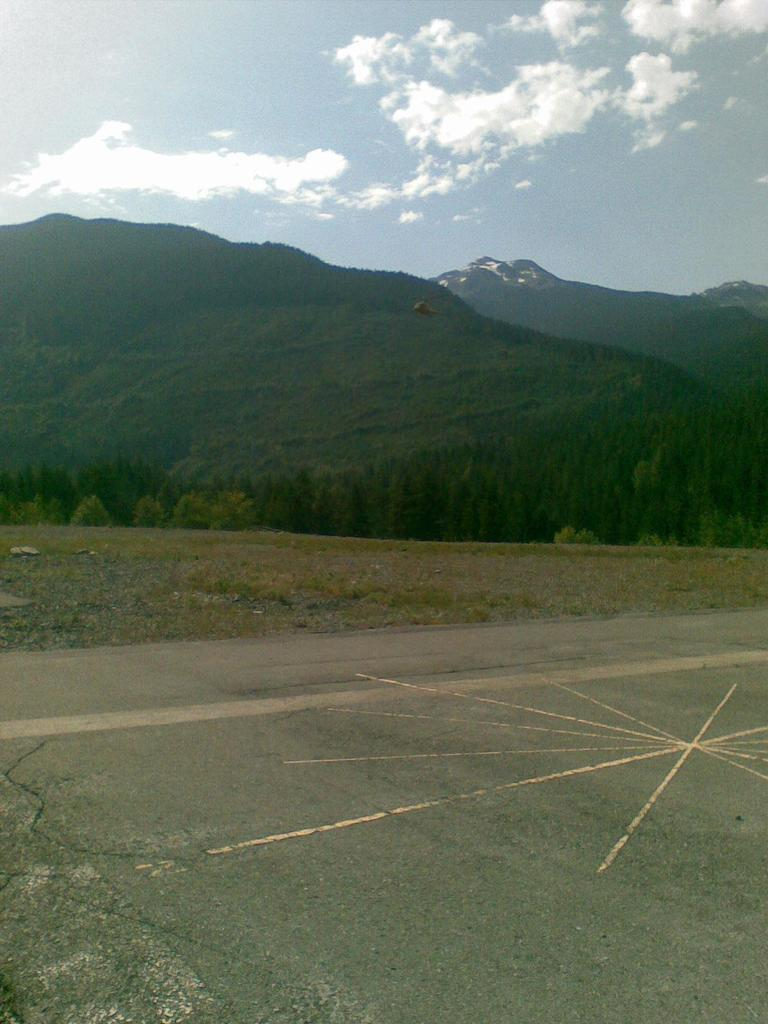What is flying in the image? There is a helicopter flying in the image. What type of natural features can be seen in the image? There are trees and hills in the image. What is visible in the background of the image? The sky is visible in the background of the image. What type of station can be seen in the image? There is no station present in the image; it features a helicopter flying over trees and hills with the sky visible in the background. 